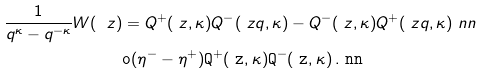Convert formula to latex. <formula><loc_0><loc_0><loc_500><loc_500>\frac { 1 } { q ^ { \kappa } - q ^ { - \kappa } } W ( \ z ) & = Q ^ { + } ( \ z , \kappa ) Q ^ { - } ( \ z q , \kappa ) - Q ^ { - } ( \ z , \kappa ) Q ^ { + } ( \ z q , \kappa ) \ n n \\ & \tt o ( \eta ^ { - } - \eta ^ { + } ) Q ^ { + } ( \ z , \kappa ) Q ^ { - } ( \ z , \kappa ) \, . \ n n</formula> 